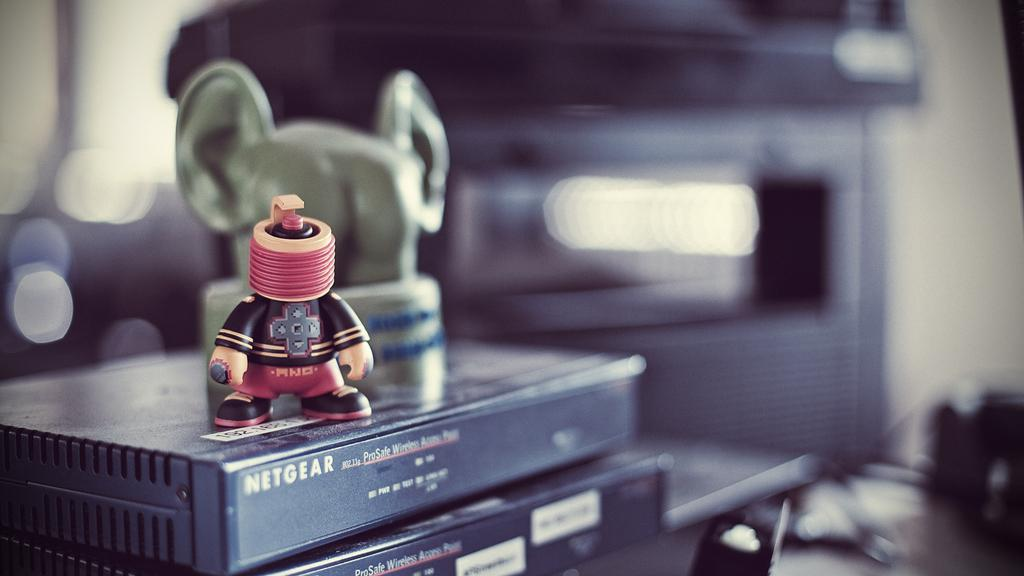<image>
Present a compact description of the photo's key features. A headless rubber toy in pink and black sits on top of a Netgear Wireless router. 